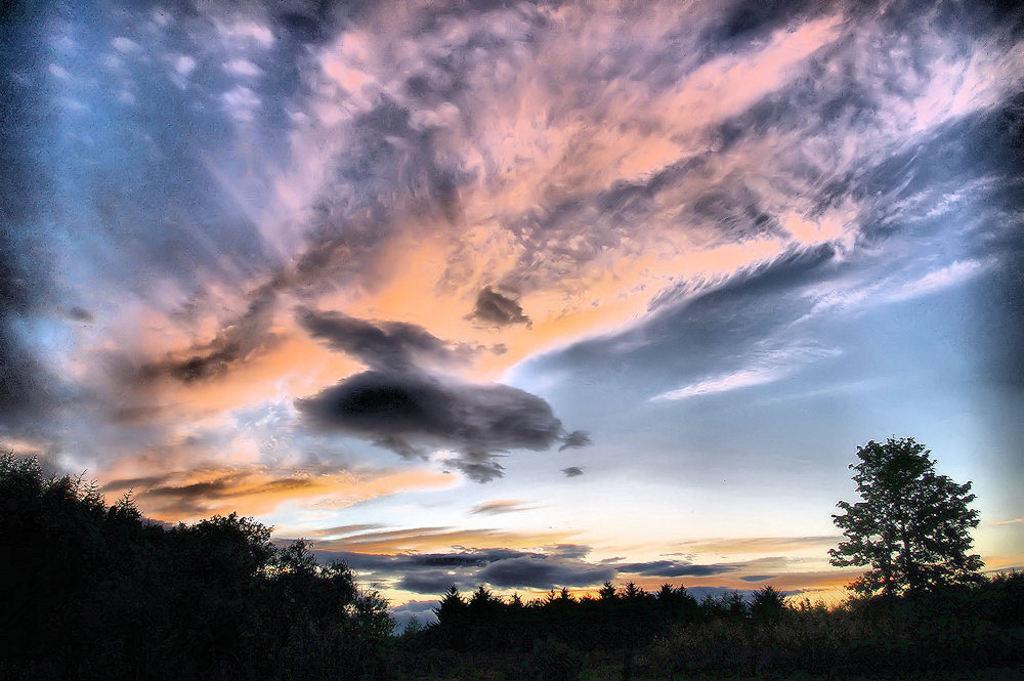Can you describe this image briefly? In this image we can see some trees and the sky which is in the color of orange, blue, white and black. 